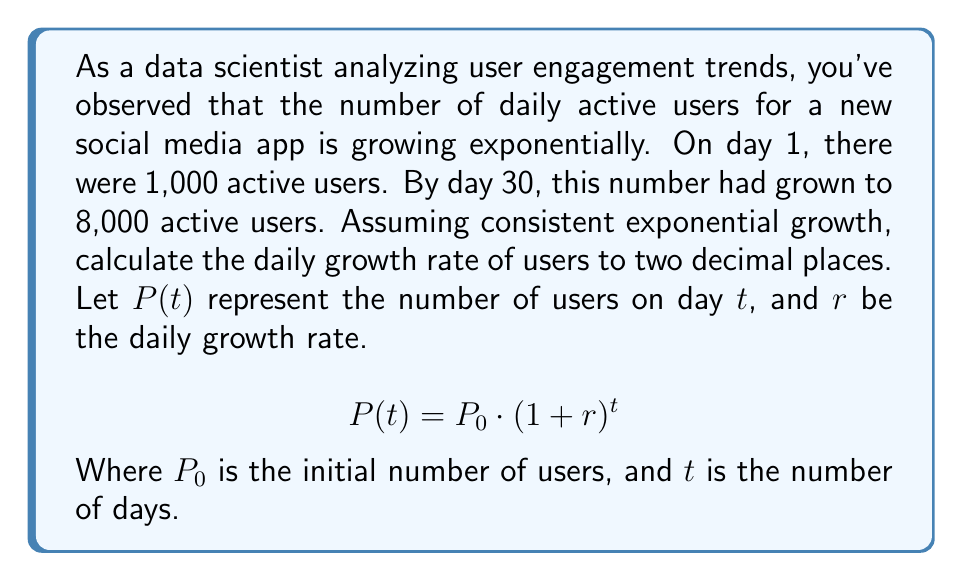What is the answer to this math problem? To solve this problem, we'll use the exponential growth formula and the given information:

1. Initial number of users, $P_0 = 1,000$
2. Number of users on day 30, $P(30) = 8,000$
3. Time period, $t = 30$ days

Let's substitute these values into the exponential growth formula:

$$8,000 = 1,000 \cdot (1+r)^{30}$$

Now, we'll solve for $r$:

1. Divide both sides by 1,000:
   $$8 = (1+r)^{30}$$

2. Take the 30th root of both sides:
   $$\sqrt[30]{8} = 1+r$$

3. Subtract 1 from both sides:
   $$\sqrt[30]{8} - 1 = r$$

4. Calculate the result:
   $$r \approx 0.0723$$

5. Convert to a percentage and round to two decimal places:
   $$r \approx 7.23\%$$

Therefore, the daily growth rate is approximately 7.23%.
Answer: 7.23% 